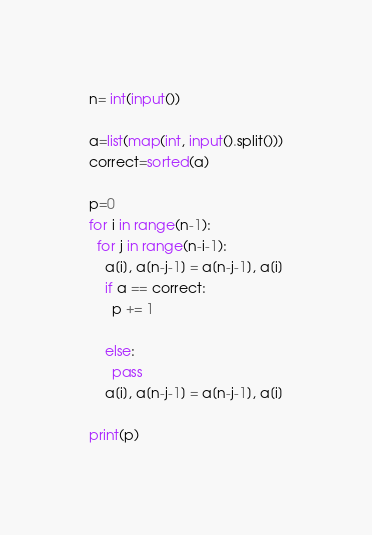<code> <loc_0><loc_0><loc_500><loc_500><_Python_>n= int(input())

a=list(map(int, input().split()))
correct=sorted(a)

p=0
for i in range(n-1):
  for j in range(n-i-1):
    a[i], a[n-j-1] = a[n-j-1], a[i]
    if a == correct:
      p += 1
      
    else:
      pass
    a[i], a[n-j-1] = a[n-j-1], a[i]
    
print(p)</code> 